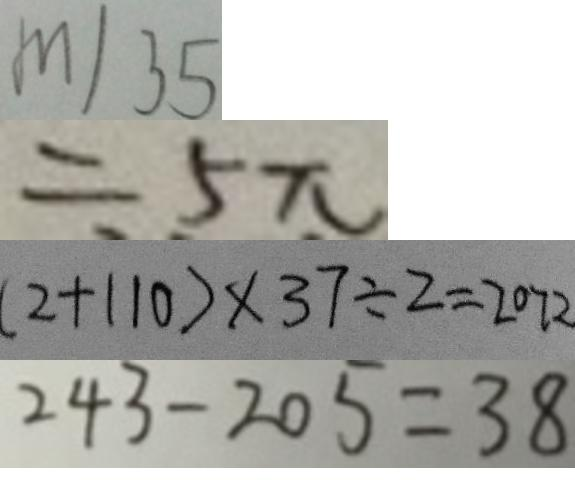Convert formula to latex. <formula><loc_0><loc_0><loc_500><loc_500>m \vert 3 5 
 = 5 \pi 
 ( 2 + 1 1 0 ) \times 3 7 \div 2 = 2 0 7 2 
 2 4 3 - 2 0 5 = 3 8</formula> 